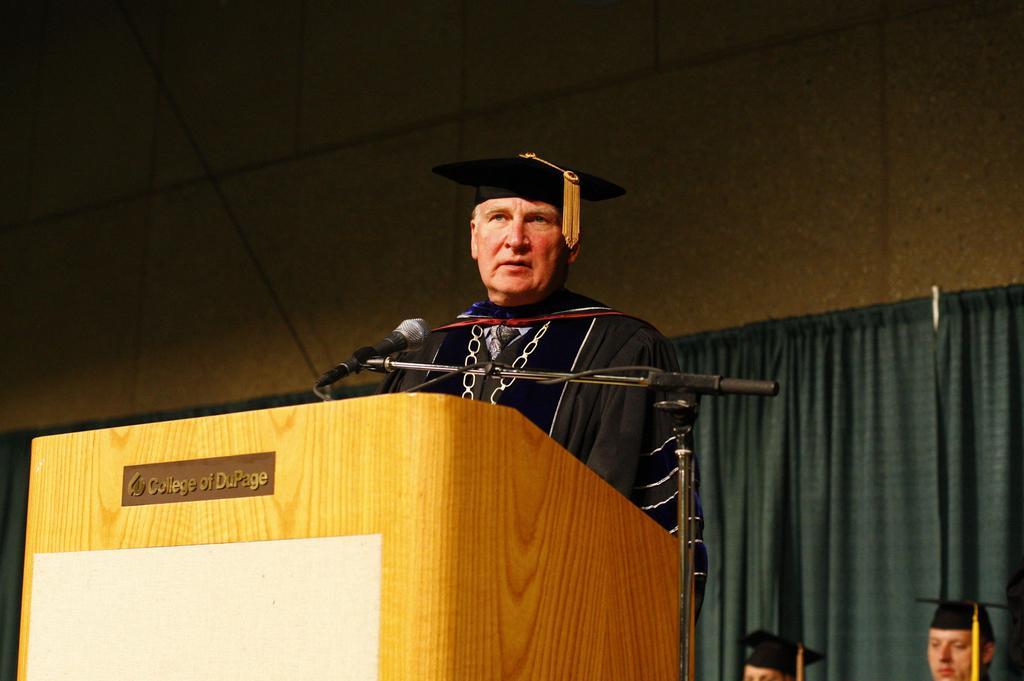In one or two sentences, can you explain what this image depicts? As we can see in the image there are curtains, wall and three people. The man over here is wearing black color dress. In front of him there is a mic. 